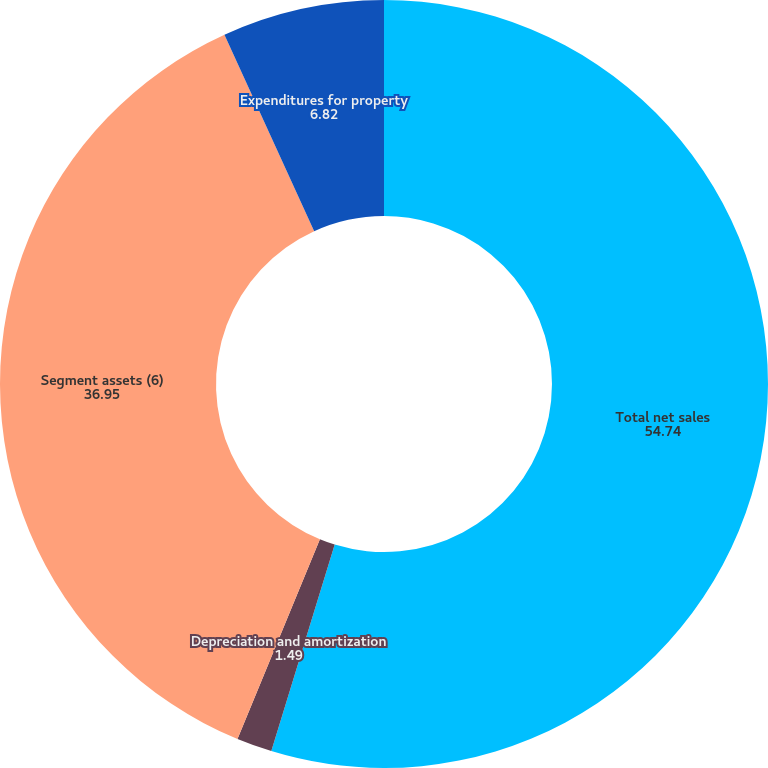Convert chart to OTSL. <chart><loc_0><loc_0><loc_500><loc_500><pie_chart><fcel>Total net sales<fcel>Depreciation and amortization<fcel>Segment assets (6)<fcel>Expenditures for property<nl><fcel>54.74%<fcel>1.49%<fcel>36.95%<fcel>6.82%<nl></chart> 